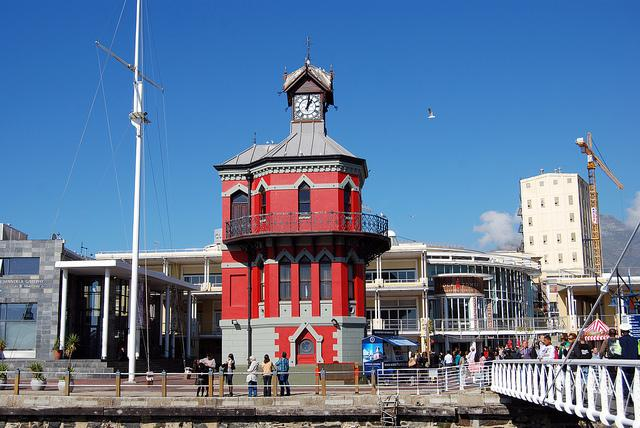What color are the rectangular bricks on the very bottom of the tower?

Choices:
A) red
B) white
C) gray
D) blue gray 